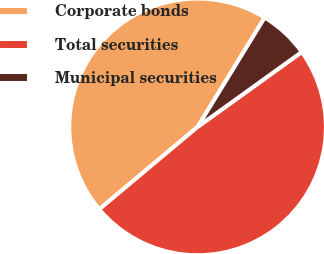Convert chart to OTSL. <chart><loc_0><loc_0><loc_500><loc_500><pie_chart><fcel>Corporate bonds<fcel>Total securities<fcel>Municipal securities<nl><fcel>44.86%<fcel>48.82%<fcel>6.32%<nl></chart> 